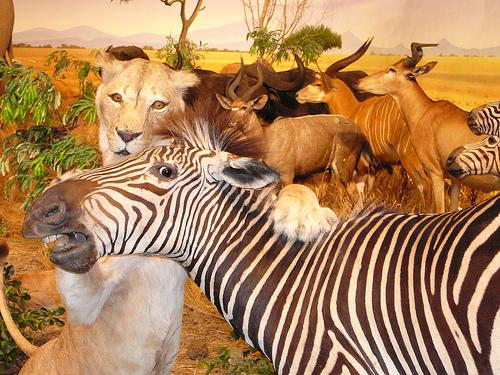In what type of environment are the animals situated? The animals are situated in a jungle or bush environment. Describe the action that the lion is taking towards the zebra. The lion is attacking the zebra by placing its paw on the zebra's back. What is the mood of the scene depicted in the image? The mood of the scene is tense and dramatic, as the lion is attacking the zebra. What features distinguish a zebra in the image from the other animals? The zebra can be distinguished by its black and white stripes, black nose, and mouth opened. Provide a brief description of the scene depicted in the image. The image shows various animals such as a lion, zebras, and antelopes in a jungle setting, with a lion attacking a zebra while other animals surround them. Describe the physical appearance of the lion and how it is positioned in the image. The lion has beautiful yellow eyes and brown eyes, its head is above the zebra's head, and its paw is positioned on the zebra's back. How many zebras and lions can you identify in the picture? There are at least two zebras and one lion in the picture. Identify the presence of any less common animals in the image and describe their appearance. There are brown and grey antelope with long curved antlers, and a gazelle with horns. What are the most dominant colors of the animals shown in the image? Black, white, brown, and grey are the dominant colors of the animals in the image. Mention the key interaction between two animals in this image. The key interaction is a lion attacking a zebra, with its paw on the zebra's back. Explain the visual relationship between the lion's head and the zebra's head. Lion head is positioned above zebra head What information would you need to answer a knowledge-intensive question about the lifestyle of lions and zebras? Information about their habitats, diets, social behaviors, and predator-prey relationships. Are there purple stripes on the zebra at X:346 Y:99? There are white stripes on the animal at the specified position, not purple. Locate the small green tree in the scene. On the top right part of the picture What is the main event happening between the lion and zebra? The event is a lion attacking a zebra Is there a pink lion paw on the zebra's back at X:261 Y:180? While there is a lion paw on the zebra's back at the specified position, it is not pink. Select the correct description of the antelope in the image. Options: A) Brown antelope with striped horns, B) Brown antelope with antlers, C) Gray antelope with short horns. B) Brown antelope with antlers Is the lion depicted with green eyes at X:87 Y:82? The lion at the given position has yellow eyes, not green. Identify any emotions displayed by the animals. There is no clear facial Expression Detection in the image. Extract text information from the image, if any. No text information is present in the image. Can you find a tiny elephant in the jungle at X:20 Y:43? There is an image of animals in the jungle at the specified position, but there is no mention of a tiny elephant. Describe the color of the lions' eyes. The lion has beautiful yellow eyes. What is the color of the cat depicted in the picture? Black and white Create a multi-modal visual and textual representation of the scene with the lion attacking the zebra. [Image of a lion attacking a zebra], Caption: "A fierce lion leaps onto a helpless zebra in the wild African bush." What are the colors of the zebra in the museum? White and black Which animal has a white mound on its back? Zebra Identify the position of the zebra's open mouth based on a referential phrase. Top left area of the image Describe the activity taking place between two main animals in the picture. A lion is attacking a zebra What is the primary color of the tree growing in the bush? Green Provide a short description of the main action taking place between the lion and the zebra. Lion attacking and jumping on a zebra What kind of scene is depicted in the image? A bush scene in Africa with animals in the jungle Are there birds flying over the mountain range at X:32 Y:12? There is a tall mountain range mentioned at the specified position, but there are no birds mentioned as flying over it. Describe the appearance of the antlers on the antelope. Long curved grey antlers Write an artistically styled caption for the image. In the vibrant African bush, a fierce lion leaps onto a monochrome zebra, as intrigued antelopes observe the dramatic scene. Is the zebra with a blue nose at X:4 Y:193? There is a zebra in the mentioned position, but its nose is black, not blue. 